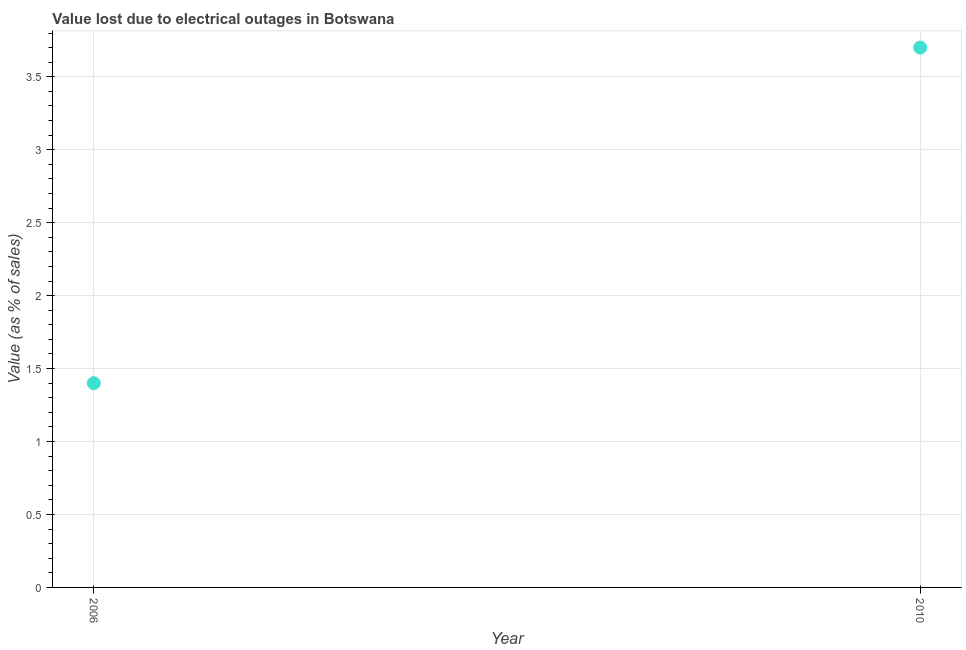Across all years, what is the minimum value lost due to electrical outages?
Offer a very short reply. 1.4. In which year was the value lost due to electrical outages minimum?
Your answer should be compact. 2006. What is the difference between the value lost due to electrical outages in 2006 and 2010?
Offer a terse response. -2.3. What is the average value lost due to electrical outages per year?
Make the answer very short. 2.55. What is the median value lost due to electrical outages?
Give a very brief answer. 2.55. What is the ratio of the value lost due to electrical outages in 2006 to that in 2010?
Your answer should be very brief. 0.38. Does the value lost due to electrical outages monotonically increase over the years?
Make the answer very short. Yes. How many dotlines are there?
Provide a short and direct response. 1. How many years are there in the graph?
Your answer should be very brief. 2. What is the difference between two consecutive major ticks on the Y-axis?
Provide a short and direct response. 0.5. Does the graph contain any zero values?
Ensure brevity in your answer.  No. What is the title of the graph?
Provide a succinct answer. Value lost due to electrical outages in Botswana. What is the label or title of the X-axis?
Your answer should be compact. Year. What is the label or title of the Y-axis?
Your response must be concise. Value (as % of sales). What is the difference between the Value (as % of sales) in 2006 and 2010?
Your answer should be very brief. -2.3. What is the ratio of the Value (as % of sales) in 2006 to that in 2010?
Keep it short and to the point. 0.38. 